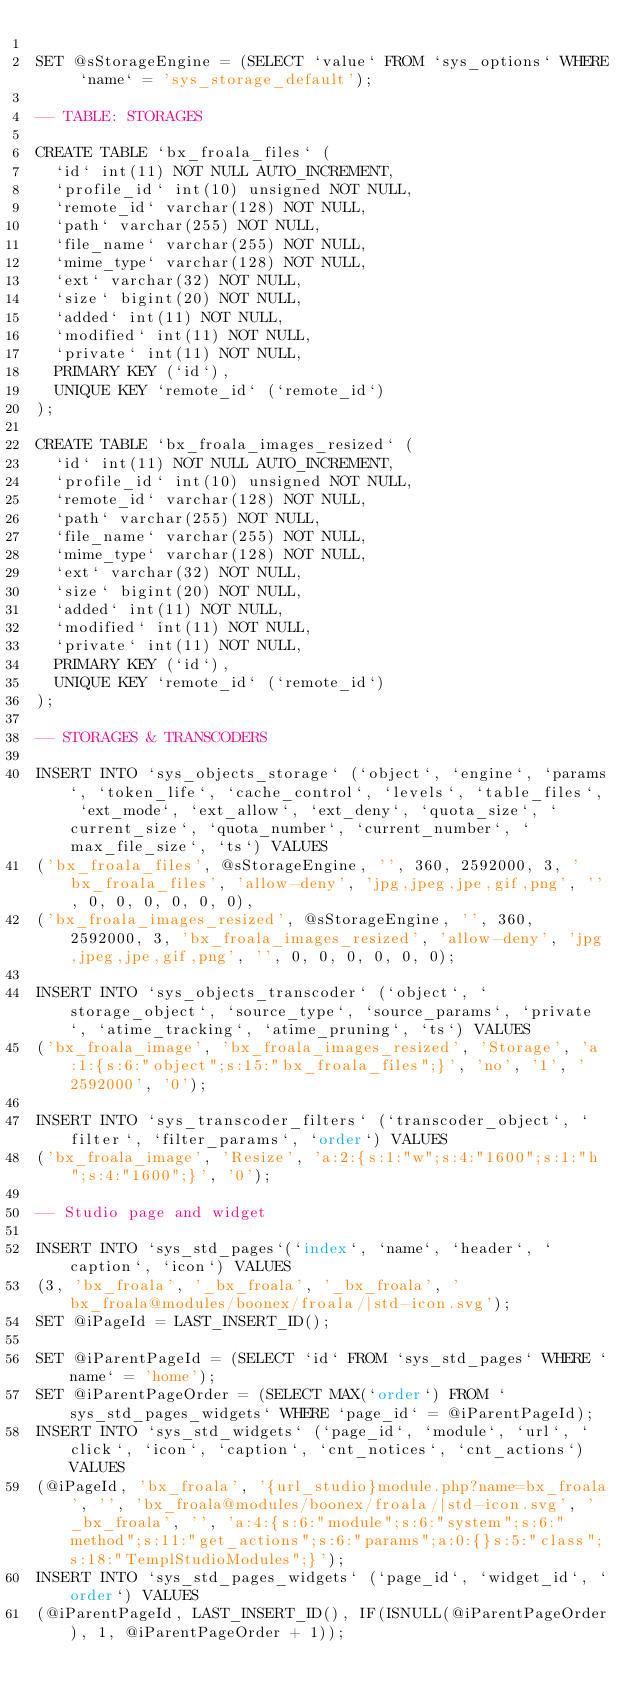Convert code to text. <code><loc_0><loc_0><loc_500><loc_500><_SQL_>
SET @sStorageEngine = (SELECT `value` FROM `sys_options` WHERE `name` = 'sys_storage_default');

-- TABLE: STORAGES

CREATE TABLE `bx_froala_files` (
  `id` int(11) NOT NULL AUTO_INCREMENT,
  `profile_id` int(10) unsigned NOT NULL,
  `remote_id` varchar(128) NOT NULL,
  `path` varchar(255) NOT NULL,
  `file_name` varchar(255) NOT NULL,
  `mime_type` varchar(128) NOT NULL,
  `ext` varchar(32) NOT NULL,
  `size` bigint(20) NOT NULL,
  `added` int(11) NOT NULL,
  `modified` int(11) NOT NULL,
  `private` int(11) NOT NULL,
  PRIMARY KEY (`id`),
  UNIQUE KEY `remote_id` (`remote_id`)
);

CREATE TABLE `bx_froala_images_resized` (
  `id` int(11) NOT NULL AUTO_INCREMENT,
  `profile_id` int(10) unsigned NOT NULL,
  `remote_id` varchar(128) NOT NULL,
  `path` varchar(255) NOT NULL,
  `file_name` varchar(255) NOT NULL,
  `mime_type` varchar(128) NOT NULL,
  `ext` varchar(32) NOT NULL,
  `size` bigint(20) NOT NULL,
  `added` int(11) NOT NULL,
  `modified` int(11) NOT NULL,
  `private` int(11) NOT NULL,
  PRIMARY KEY (`id`),
  UNIQUE KEY `remote_id` (`remote_id`)
);

-- STORAGES & TRANSCODERS

INSERT INTO `sys_objects_storage` (`object`, `engine`, `params`, `token_life`, `cache_control`, `levels`, `table_files`, `ext_mode`, `ext_allow`, `ext_deny`, `quota_size`, `current_size`, `quota_number`, `current_number`, `max_file_size`, `ts`) VALUES
('bx_froala_files', @sStorageEngine, '', 360, 2592000, 3, 'bx_froala_files', 'allow-deny', 'jpg,jpeg,jpe,gif,png', '', 0, 0, 0, 0, 0, 0),
('bx_froala_images_resized', @sStorageEngine, '', 360, 2592000, 3, 'bx_froala_images_resized', 'allow-deny', 'jpg,jpeg,jpe,gif,png', '', 0, 0, 0, 0, 0, 0);

INSERT INTO `sys_objects_transcoder` (`object`, `storage_object`, `source_type`, `source_params`, `private`, `atime_tracking`, `atime_pruning`, `ts`) VALUES 
('bx_froala_image', 'bx_froala_images_resized', 'Storage', 'a:1:{s:6:"object";s:15:"bx_froala_files";}', 'no', '1', '2592000', '0');

INSERT INTO `sys_transcoder_filters` (`transcoder_object`, `filter`, `filter_params`, `order`) VALUES 
('bx_froala_image', 'Resize', 'a:2:{s:1:"w";s:4:"1600";s:1:"h";s:4:"1600";}', '0');

-- Studio page and widget

INSERT INTO `sys_std_pages`(`index`, `name`, `header`, `caption`, `icon`) VALUES
(3, 'bx_froala', '_bx_froala', '_bx_froala', 'bx_froala@modules/boonex/froala/|std-icon.svg');
SET @iPageId = LAST_INSERT_ID();

SET @iParentPageId = (SELECT `id` FROM `sys_std_pages` WHERE `name` = 'home');
SET @iParentPageOrder = (SELECT MAX(`order`) FROM `sys_std_pages_widgets` WHERE `page_id` = @iParentPageId);
INSERT INTO `sys_std_widgets` (`page_id`, `module`, `url`, `click`, `icon`, `caption`, `cnt_notices`, `cnt_actions`) VALUES
(@iPageId, 'bx_froala', '{url_studio}module.php?name=bx_froala', '', 'bx_froala@modules/boonex/froala/|std-icon.svg', '_bx_froala', '', 'a:4:{s:6:"module";s:6:"system";s:6:"method";s:11:"get_actions";s:6:"params";a:0:{}s:5:"class";s:18:"TemplStudioModules";}');
INSERT INTO `sys_std_pages_widgets` (`page_id`, `widget_id`, `order`) VALUES
(@iParentPageId, LAST_INSERT_ID(), IF(ISNULL(@iParentPageOrder), 1, @iParentPageOrder + 1));

</code> 